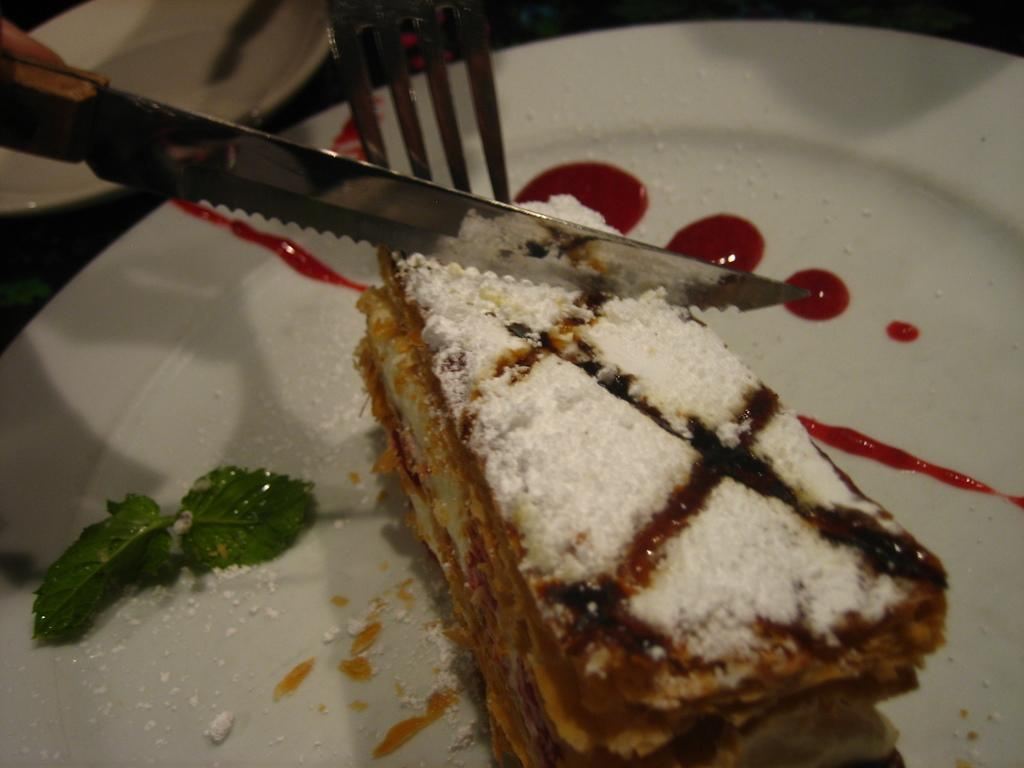How many plates can be seen in the image? There are two plates in the image. What is the color of one of the plates? One of the plates is white. What is on the white plate? There is food on the white plate. What utensils are present above the food on the white plate? A fork and knife are present above the food on the white plate. What type of basket is used to transport patients in the image? There is no basket or hospital setting present in the image; it features two plates with food and utensils. 